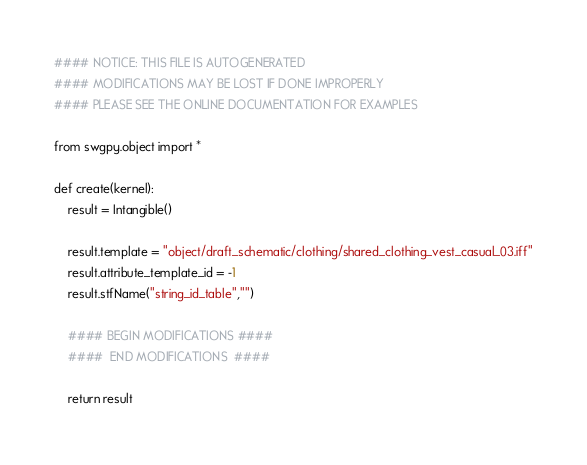Convert code to text. <code><loc_0><loc_0><loc_500><loc_500><_Python_>#### NOTICE: THIS FILE IS AUTOGENERATED
#### MODIFICATIONS MAY BE LOST IF DONE IMPROPERLY
#### PLEASE SEE THE ONLINE DOCUMENTATION FOR EXAMPLES

from swgpy.object import *	

def create(kernel):
	result = Intangible()

	result.template = "object/draft_schematic/clothing/shared_clothing_vest_casual_03.iff"
	result.attribute_template_id = -1
	result.stfName("string_id_table","")		
	
	#### BEGIN MODIFICATIONS ####
	####  END MODIFICATIONS  ####
	
	return result</code> 